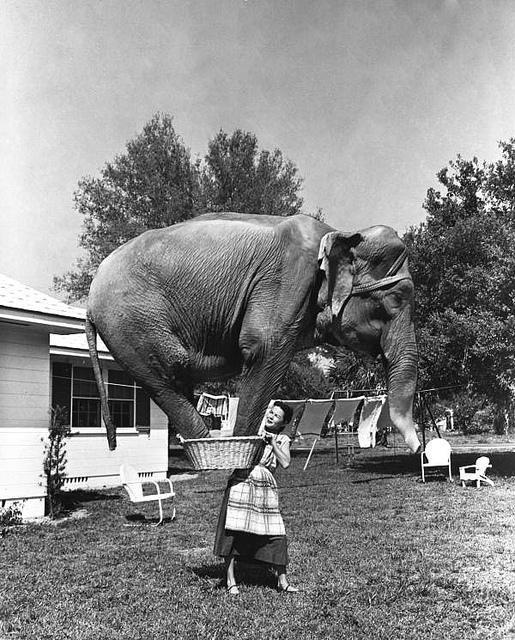How many chairs are there?
Give a very brief answer. 3. How many people can be seen?
Give a very brief answer. 1. How many cars are in the picture?
Give a very brief answer. 0. 